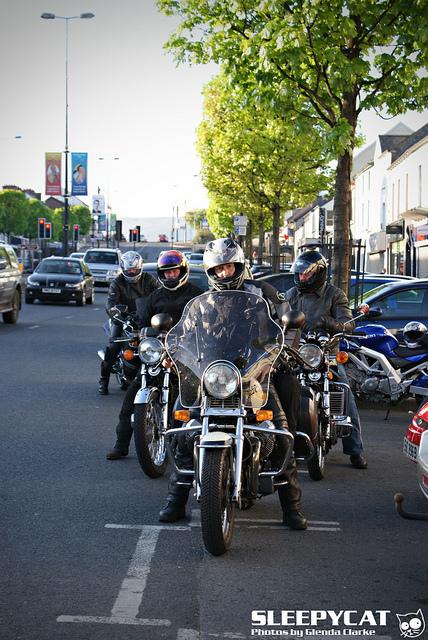How many plastic face shields are on the motorcycles?
Short answer required. 1. How many of the helmets are completely covered without showing the face?
Short answer required. 0. Are the motorcycles in a parking lot?
Short answer required. No. 